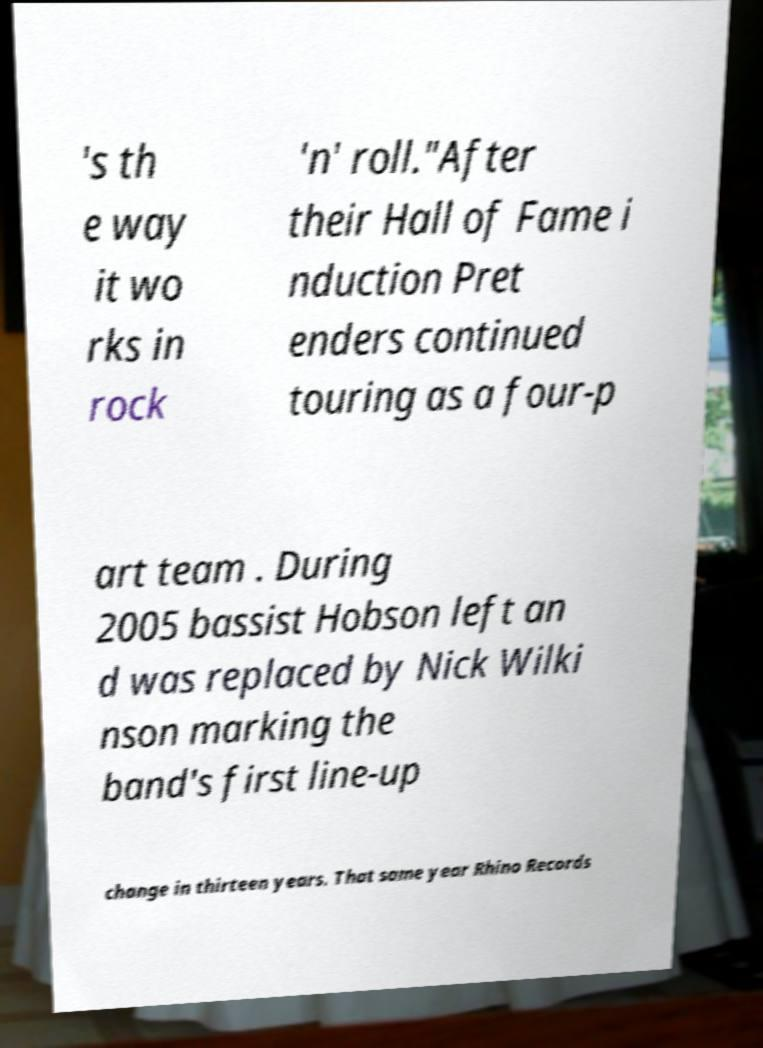Can you read and provide the text displayed in the image?This photo seems to have some interesting text. Can you extract and type it out for me? 's th e way it wo rks in rock 'n' roll."After their Hall of Fame i nduction Pret enders continued touring as a four-p art team . During 2005 bassist Hobson left an d was replaced by Nick Wilki nson marking the band's first line-up change in thirteen years. That same year Rhino Records 